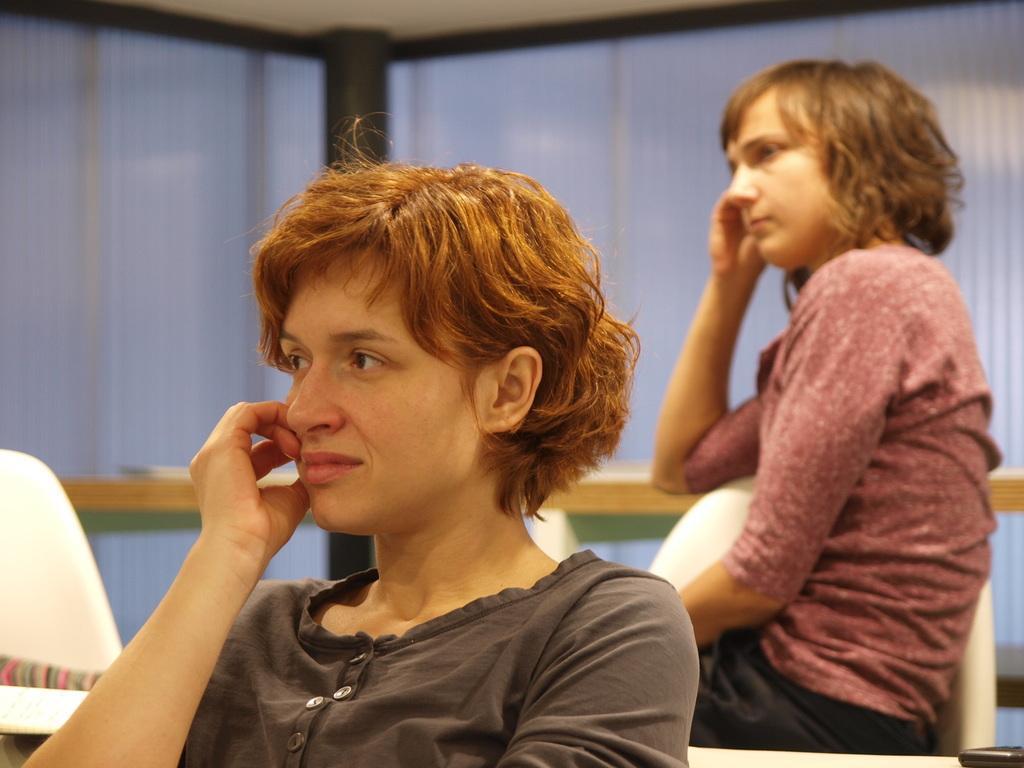Describe this image in one or two sentences. In this image there are two girls sitting on their chairs and looking to the left side of the image, behind them there is a table. In the background there is a wall. 